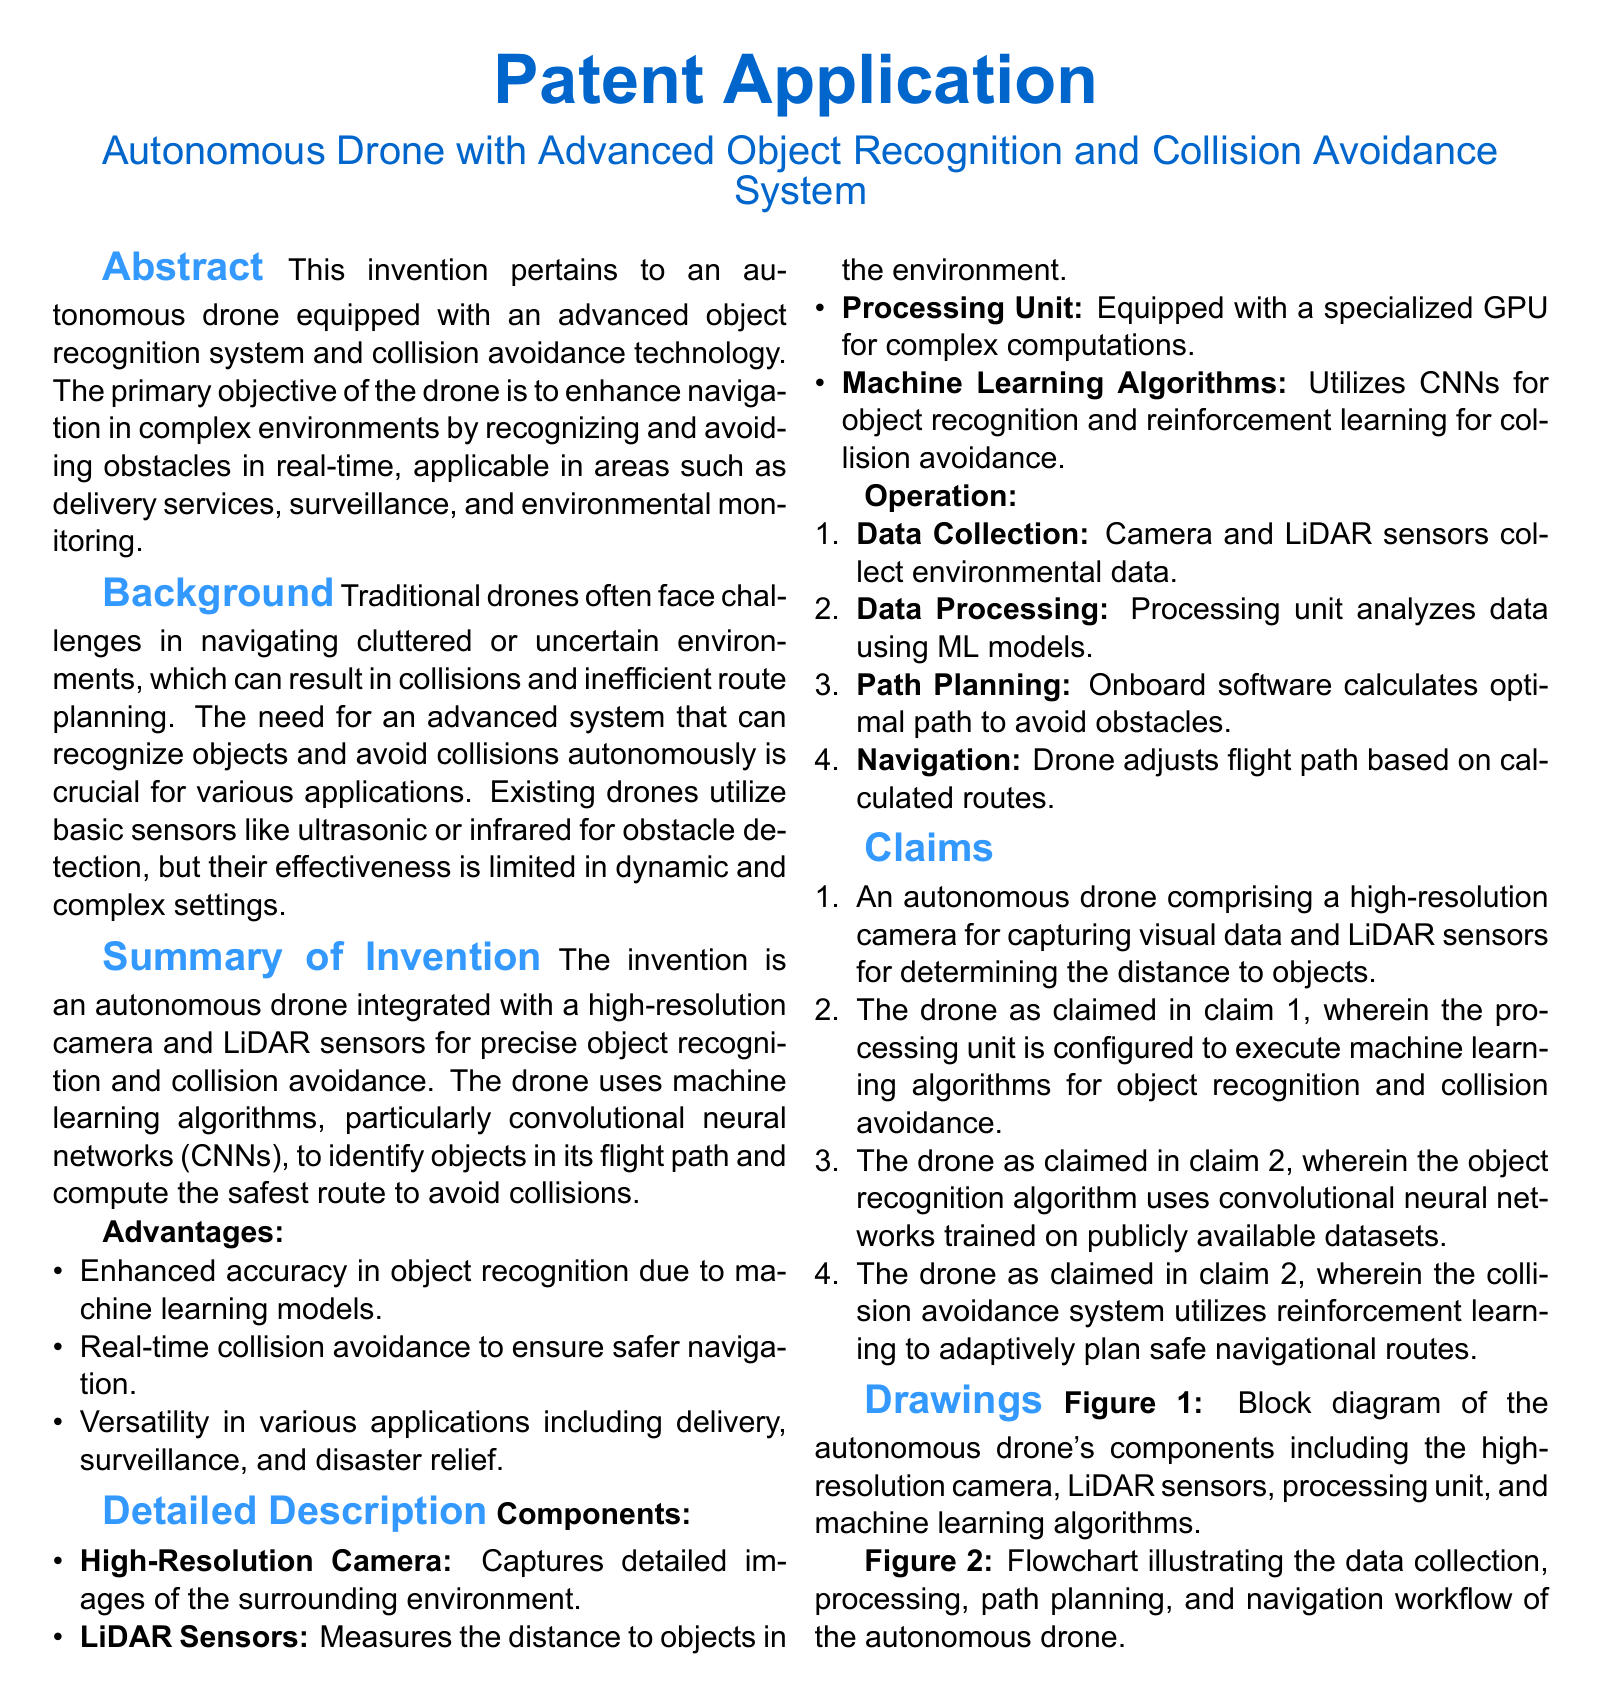What is the title of the patent application? The title is stated in the document's heading, summarizing the invention's purpose.
Answer: Autonomous Drone with Advanced Object Recognition and Collision Avoidance System What are LiDAR sensors used for in the drone? The document specifies that LiDAR sensors measure the distance to objects in the environment.
Answer: Measuring distance to objects What machine learning models are mentioned in the invention? The document highlights convolutional neural networks and reinforcement learning as key machine learning algorithms.
Answer: Convolutional neural networks and reinforcement learning What is one advantage of the drone mentioned in the document? The advantages section lists enhanced accuracy in object recognition due to machine learning models as a key benefit.
Answer: Enhanced accuracy in object recognition How many claims are listed in the document? The claims section enumerates the features of the drone, providing a total count of specific claims.
Answer: Four claims What is the primary objective of the invention? The abstract outlines the primary objective of enhancing navigation in complex environments.
Answer: Enhance navigation in complex environments In which applications can the drone be utilized? The document mentions delivery services, surveillance, and environmental monitoring as potential application areas.
Answer: Delivery services, surveillance, and environmental monitoring What is the role of the processing unit in the drone? The processing unit is described as executing machine learning algorithms for object recognition and collision avoidance.
Answer: Executing machine learning algorithms What is depicted in Figure 1 of the document? Figure 1 is a block diagram representing the autonomous drone's components.
Answer: Block diagram of components 